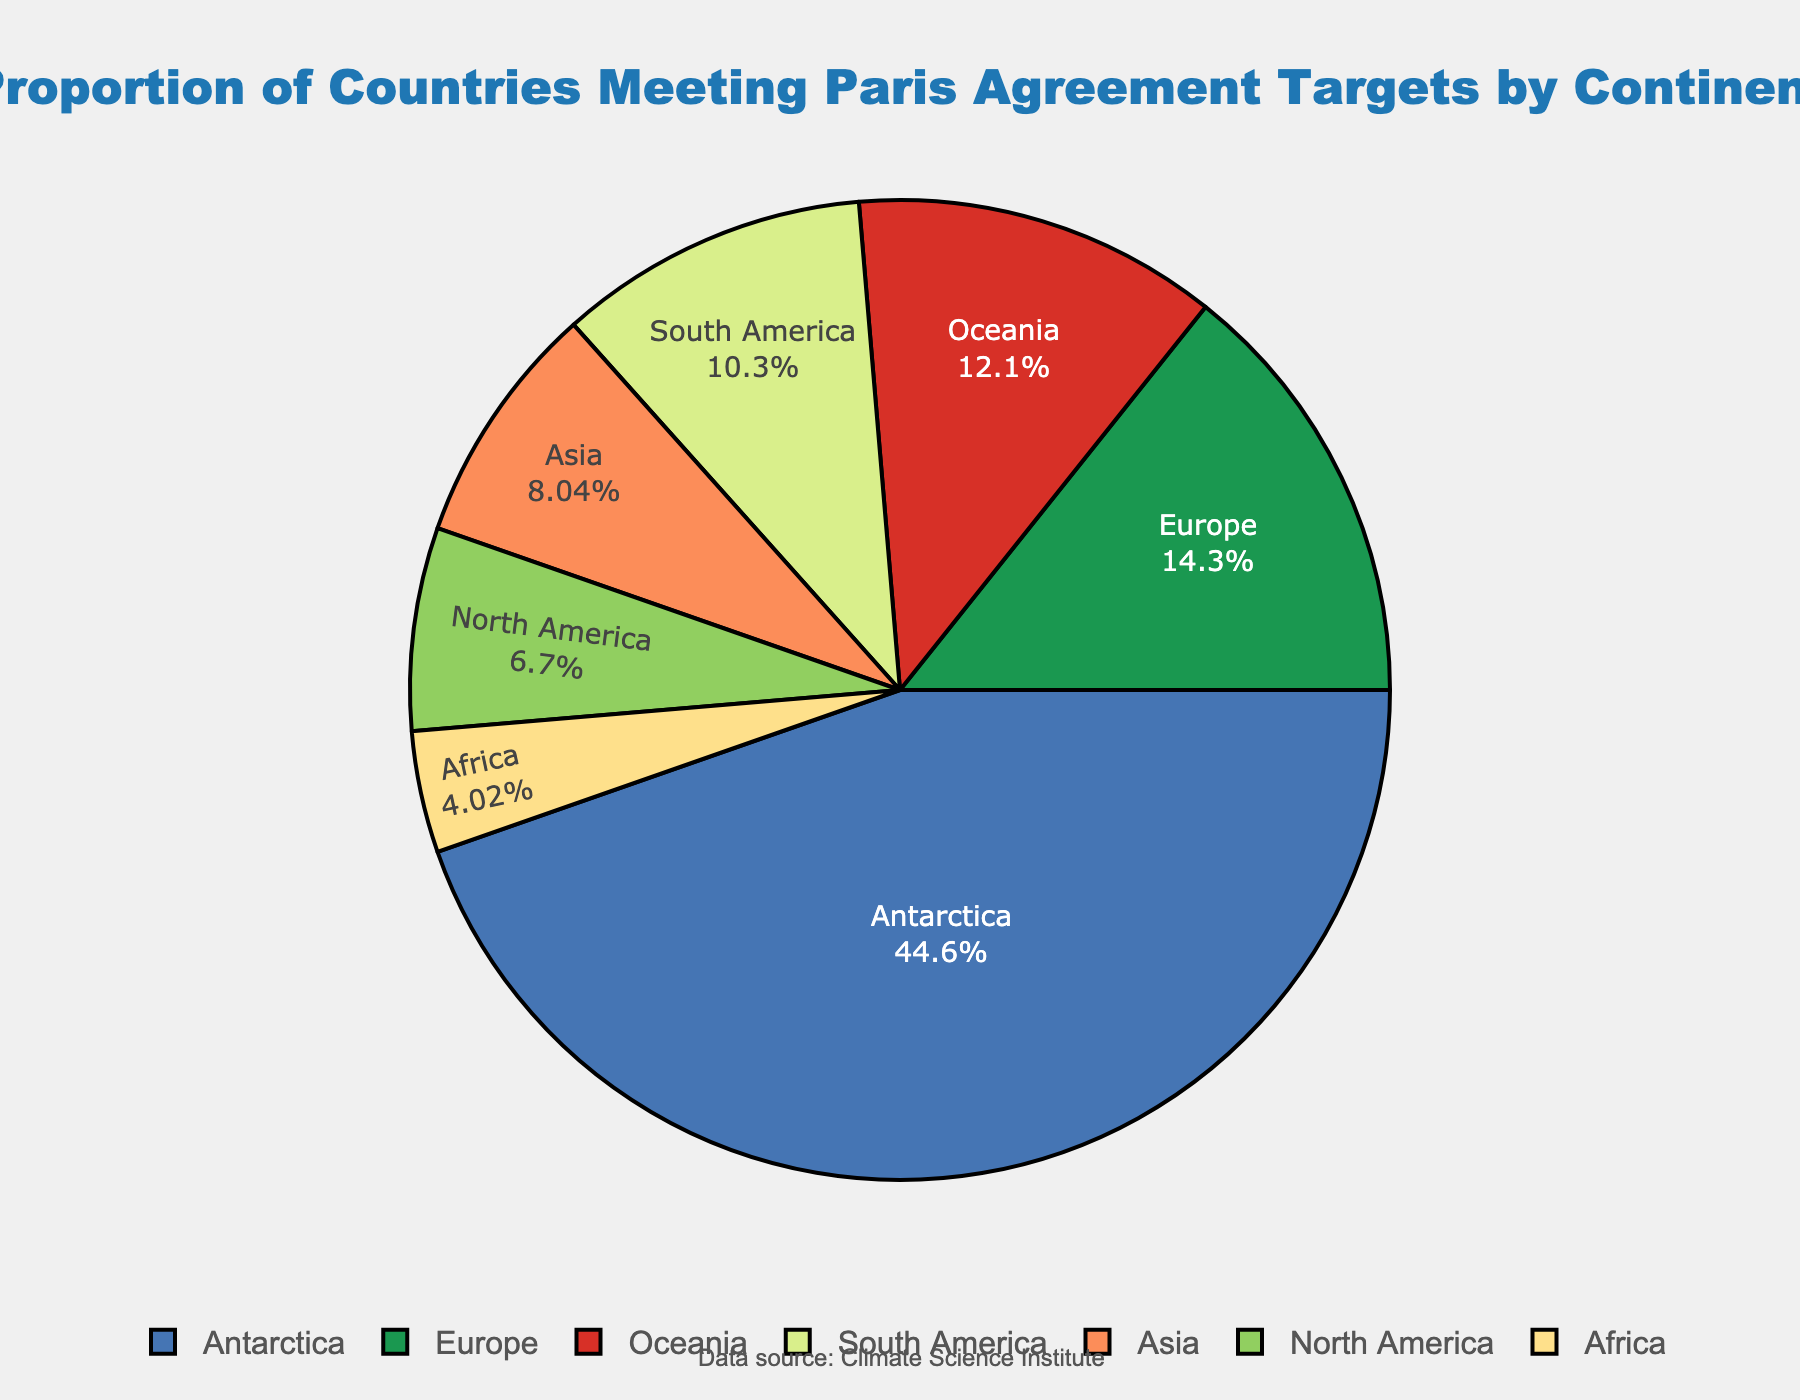Which continent has the highest proportion of countries meeting Paris Agreement targets? The continent with the highest proportion of countries meeting Paris Agreement targets is Antarctica, indicated by the largest segment on the pie chart.
Answer: Antarctica Which continent has a higher proportion of countries meeting Paris Agreement targets: Europe or North America? Comparing the proportions, Europe has a higher proportion (32%) compared to North America (15%).
Answer: Europe What is the combined proportion of countries meeting Paris Agreement targets for Asia and Africa? Adding the proportions for Asia (18%) and Africa (9%), we get 18 + 9 = 27%.
Answer: 27% How do the proportions of Oceania and South America compare? The proportion for Oceania (27%) is higher than the proportion for South America (23%).
Answer: Oceania What percentage of the total figure do Europe and Oceania together represent? Summing the percentages for Europe (32%) and Oceania (27%), we get 32 + 27 = 59%.
Answer: 59% Which continent has the smallest proportion of countries meeting the Paris Agreement targets? The smallest proportion is represented by Africa with 9%.
Answer: Africa Is the proportion of countries meeting targets in South America greater than or less than the proportion in Asia? The proportion for South America (23%) is greater than that for Asia (18%).
Answer: Greater By how much does Europe exceed North America's proportion of countries meeting targets? The difference between Europe (32%) and North America (15%) is 32 - 15 = 17%.
Answer: 17% Are there any continents with the same proportion of countries meeting the Paris Agreement targets? No, each continent has a unique proportion as indicated by the pie chart.
Answer: No What's the average proportion of countries meeting the Paris Agreement targets for all continents excluding Antarctica? Summing the proportions for continents excluding Antarctica: 32% (Europe) + 15% (North America) + 23% (South America) + 9% (Africa) + 18% (Asia) + 27% (Oceania) = 124%. There are 6 continents excluding Antarctica, so the average is 124 / 6 ≈ 20.67%.
Answer: 20.67% 